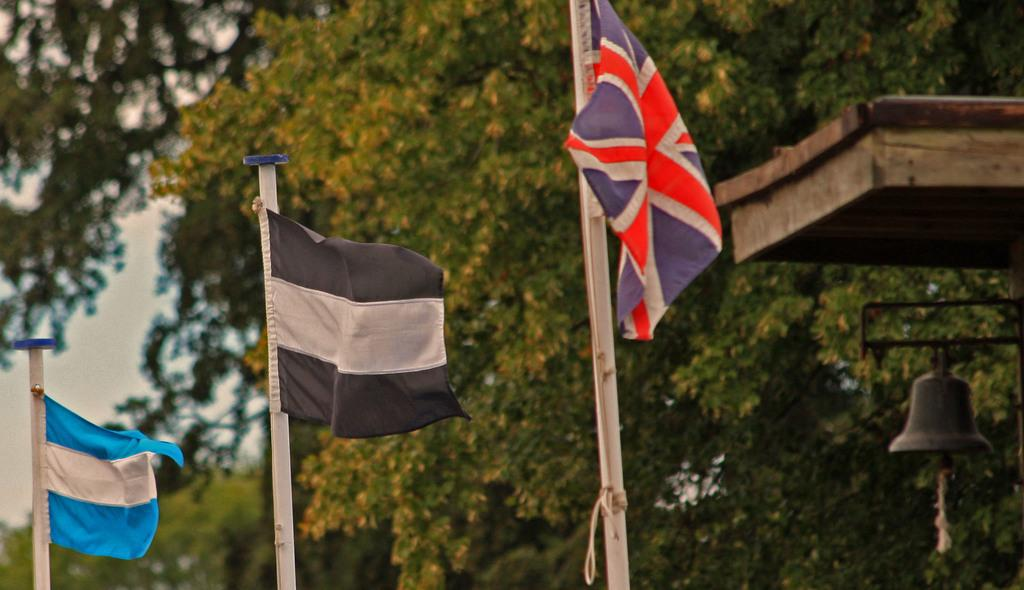How many flags are visible in the image? There are three flags in the image. What can be seen behind the flags? There are many trees behind the flags. Where is the bell located in the image? The bell is on the right side of the image. What type of chairs are placed near the flags in the image? There are no chairs present in the image. What is the price of the shoes visible in the image? There are no shoes present in the image. 